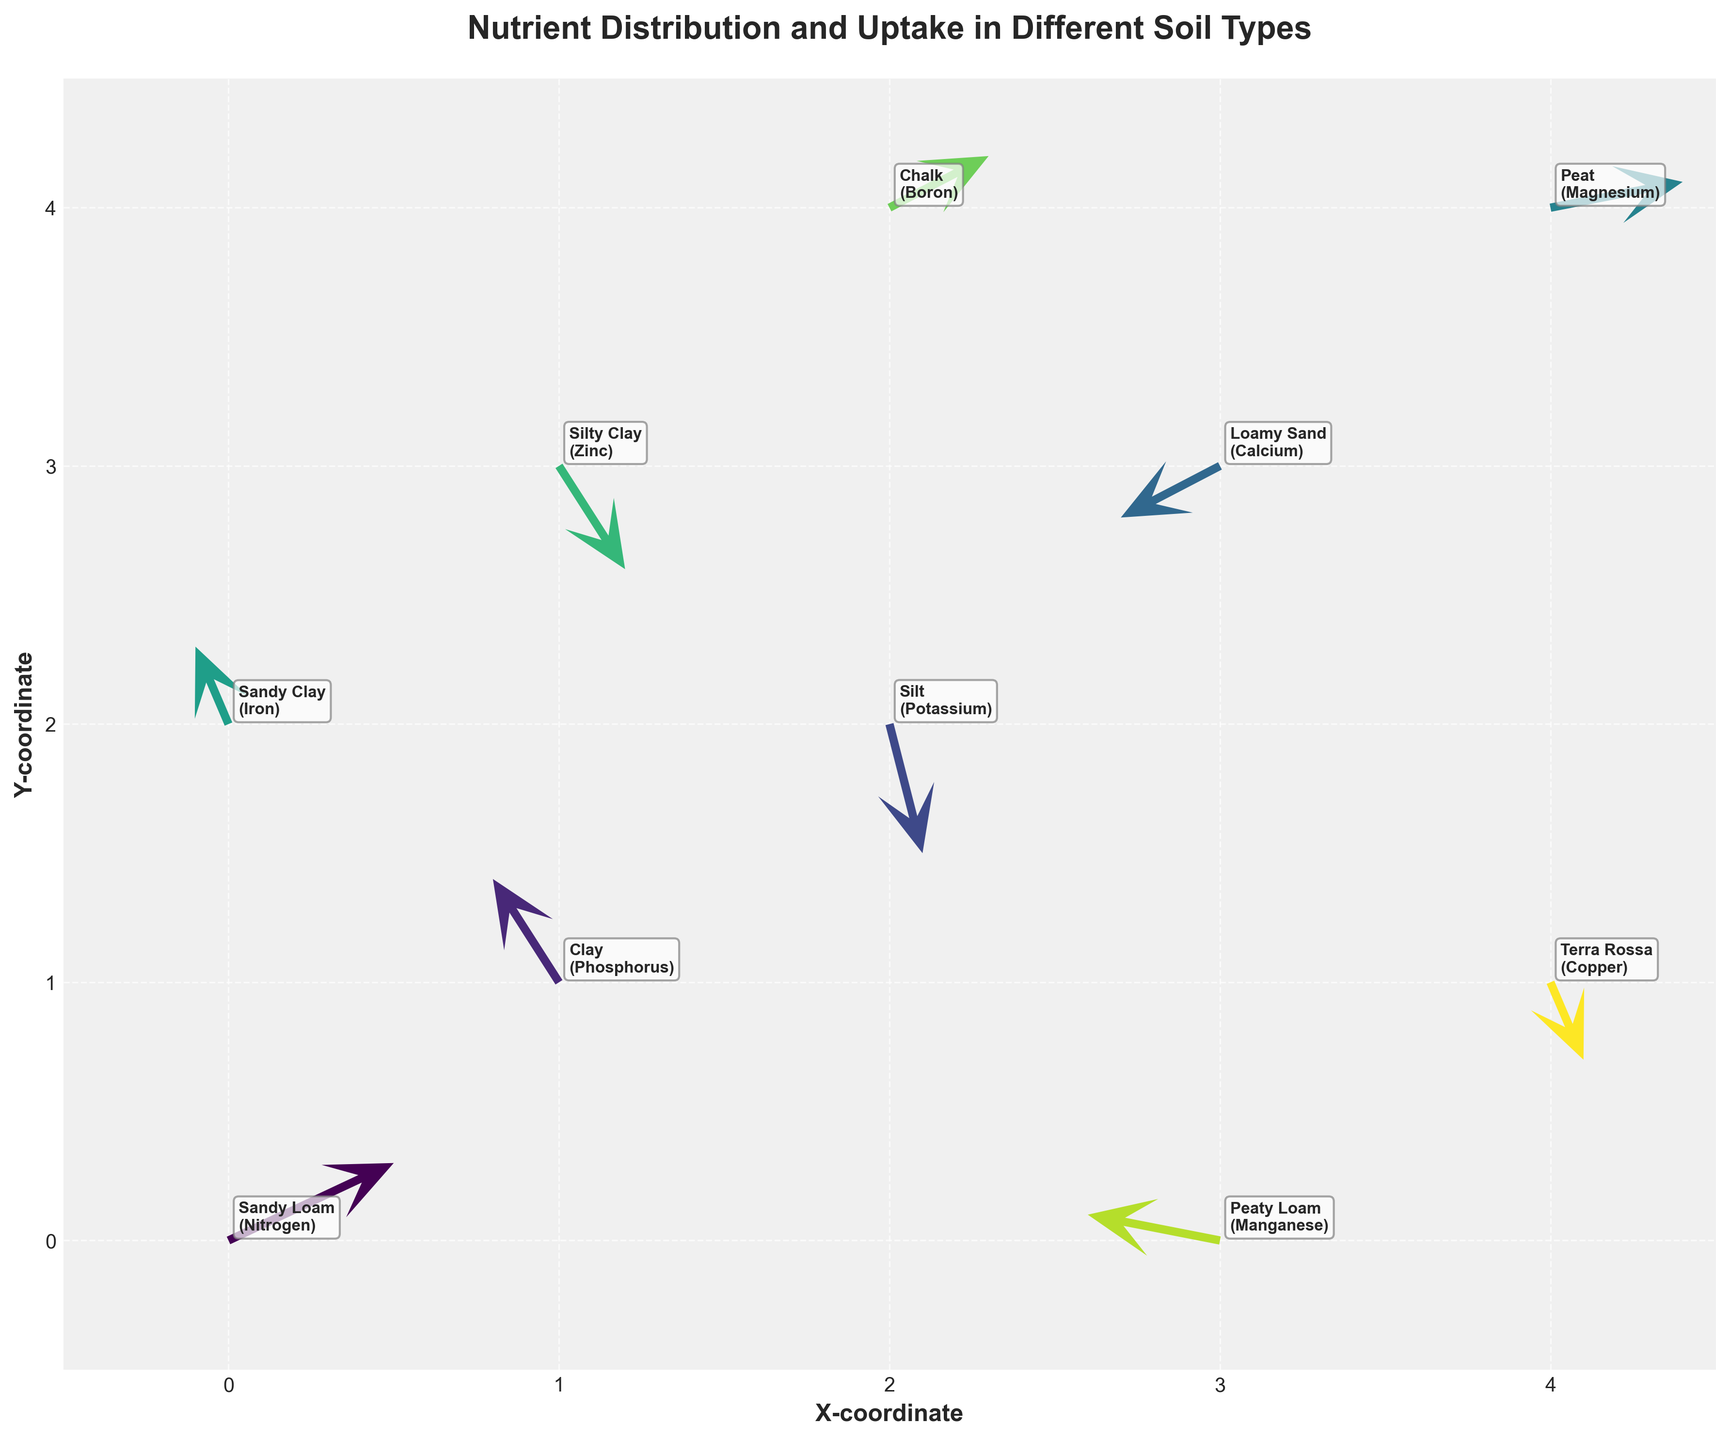How many different soil types are represented in the plot? Each arrow is annotated with the soil type. Count the number of unique annotations to find the different soil types.
Answer: 10 What is the title of the plot? The title is usually found at the top center of the plot. Read the text.
Answer: Nutrient Distribution and Uptake in Different Soil Types Which nutrient shows the largest horizontal uptake (u value)? Look at the u values for each nutrient and identify the one with the largest magnitude. In this case, it is Nitrogen with a u value of 0.5.
Answer: Nitrogen Between Calcium and Phosphorus, which soil type has the larger vertical uptake (v value)? Compare the v values in the plot. Calcium has a v value of -0.2 and Phosphorus has a v value of 0.4.
Answer: Phosphorus What are the coordinates and nutrient of the soil type labeled Loamy Sand? Find the annotation for Loamy Sand in the plot and identify its coordinates and associated nutrient.
Answer: (3, 3), Calcium Which soil type has the arrow pointing in the downward direction with the highest vertical component? Look for the arrow with the largest negative v value and check its soil type. The largest negative v value is -0.5 at coordinates (2,2) for Potassium in Silt soil.
Answer: Silt Compare the soil types Sandy Loam and Terra Rossa: which has a higher horizontal uptake value (u value)? Check their u values from the plot. Sandy Loam has a u value of 0.5 and Terra Rossa has a u value of 0.1.
Answer: Sandy Loam What is the difference in y-coordinate values for the nutrients Manganese and Zinc? Locate the y-coordinates for Manganese (0) and Zinc (3), and calculate their difference (3 - 0).
Answer: 3 If you sum up the vertical uptake (v values) for the soil types Peat and Clay, what do you get? Add the v values for Peat (0.1) and Clay (0.4) to get the total vertical uptake (0.1 + 0.4).
Answer: 0.5 Which soil type has the smallest horizontal uptake (u value)? Identify the soil type with the smallest u value. The smallest u value is -0.4, which is for the soil types labeled Silty Clay and Peaty Loam, with Peaty Loam at coordinates (3,0).
Answer: Peaty Loam 